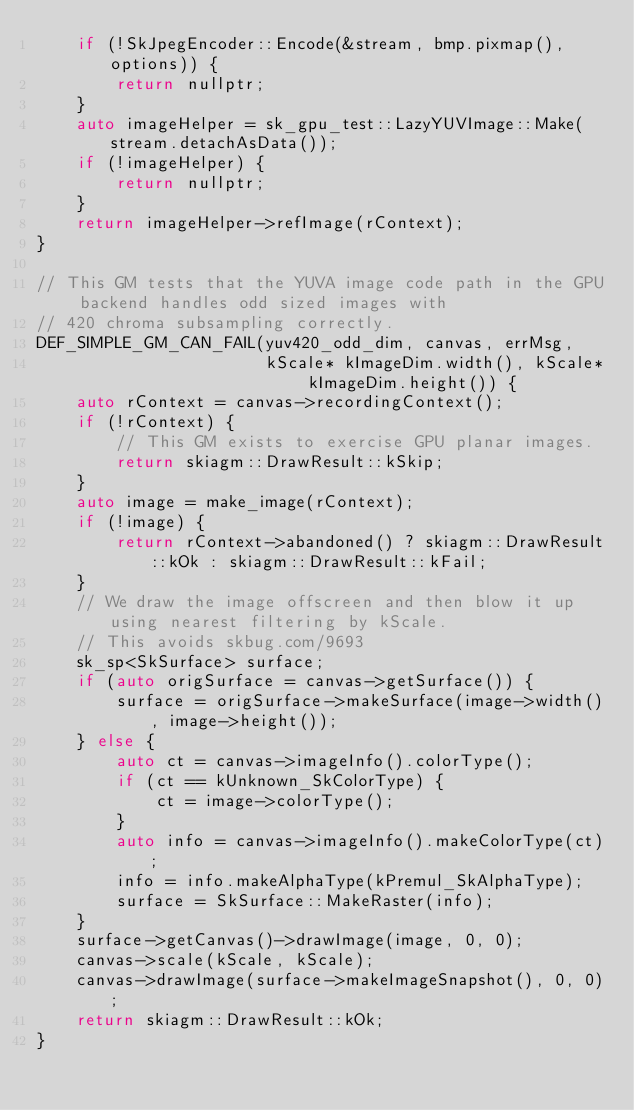Convert code to text. <code><loc_0><loc_0><loc_500><loc_500><_C++_>    if (!SkJpegEncoder::Encode(&stream, bmp.pixmap(), options)) {
        return nullptr;
    }
    auto imageHelper = sk_gpu_test::LazyYUVImage::Make(stream.detachAsData());
    if (!imageHelper) {
        return nullptr;
    }
    return imageHelper->refImage(rContext);
}

// This GM tests that the YUVA image code path in the GPU backend handles odd sized images with
// 420 chroma subsampling correctly.
DEF_SIMPLE_GM_CAN_FAIL(yuv420_odd_dim, canvas, errMsg,
                       kScale* kImageDim.width(), kScale* kImageDim.height()) {
    auto rContext = canvas->recordingContext();
    if (!rContext) {
        // This GM exists to exercise GPU planar images.
        return skiagm::DrawResult::kSkip;
    }
    auto image = make_image(rContext);
    if (!image) {
        return rContext->abandoned() ? skiagm::DrawResult::kOk : skiagm::DrawResult::kFail;
    }
    // We draw the image offscreen and then blow it up using nearest filtering by kScale.
    // This avoids skbug.com/9693
    sk_sp<SkSurface> surface;
    if (auto origSurface = canvas->getSurface()) {
        surface = origSurface->makeSurface(image->width(), image->height());
    } else {
        auto ct = canvas->imageInfo().colorType();
        if (ct == kUnknown_SkColorType) {
            ct = image->colorType();
        }
        auto info = canvas->imageInfo().makeColorType(ct);
        info = info.makeAlphaType(kPremul_SkAlphaType);
        surface = SkSurface::MakeRaster(info);
    }
    surface->getCanvas()->drawImage(image, 0, 0);
    canvas->scale(kScale, kScale);
    canvas->drawImage(surface->makeImageSnapshot(), 0, 0);
    return skiagm::DrawResult::kOk;
}
</code> 